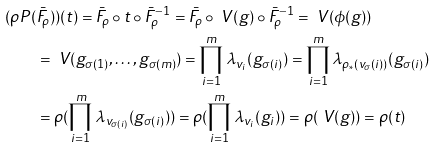<formula> <loc_0><loc_0><loc_500><loc_500>( \rho P ( & \bar { F } _ { \rho } ) ) ( t ) = \bar { F } _ { \rho } \circ t \circ \bar { F } _ { \rho } ^ { - 1 } = \bar { F } _ { \rho } \circ \ V ( g ) \circ \bar { F } _ { \rho } ^ { - 1 } = \ V ( \phi ( g ) ) \\ & = \ V ( g _ { \sigma ( 1 ) } , \dots , g _ { \sigma ( m ) } ) = \prod _ { i = 1 } ^ { m } \lambda _ { v _ { i } } ( g _ { \sigma ( i ) } ) = \prod _ { i = 1 } ^ { m } \lambda _ { \rho _ { * } ( v _ { \sigma } ( i ) ) } ( g _ { \sigma ( i ) } ) \\ & = \rho ( \prod _ { i = 1 } ^ { m } \lambda _ { v _ { \sigma ( i ) } } ( g _ { \sigma ( i ) } ) ) = \rho ( \prod _ { i = 1 } ^ { m } \lambda _ { v _ { i } } ( g _ { i } ) ) = \rho ( \ V ( g ) ) = \rho ( t )</formula> 